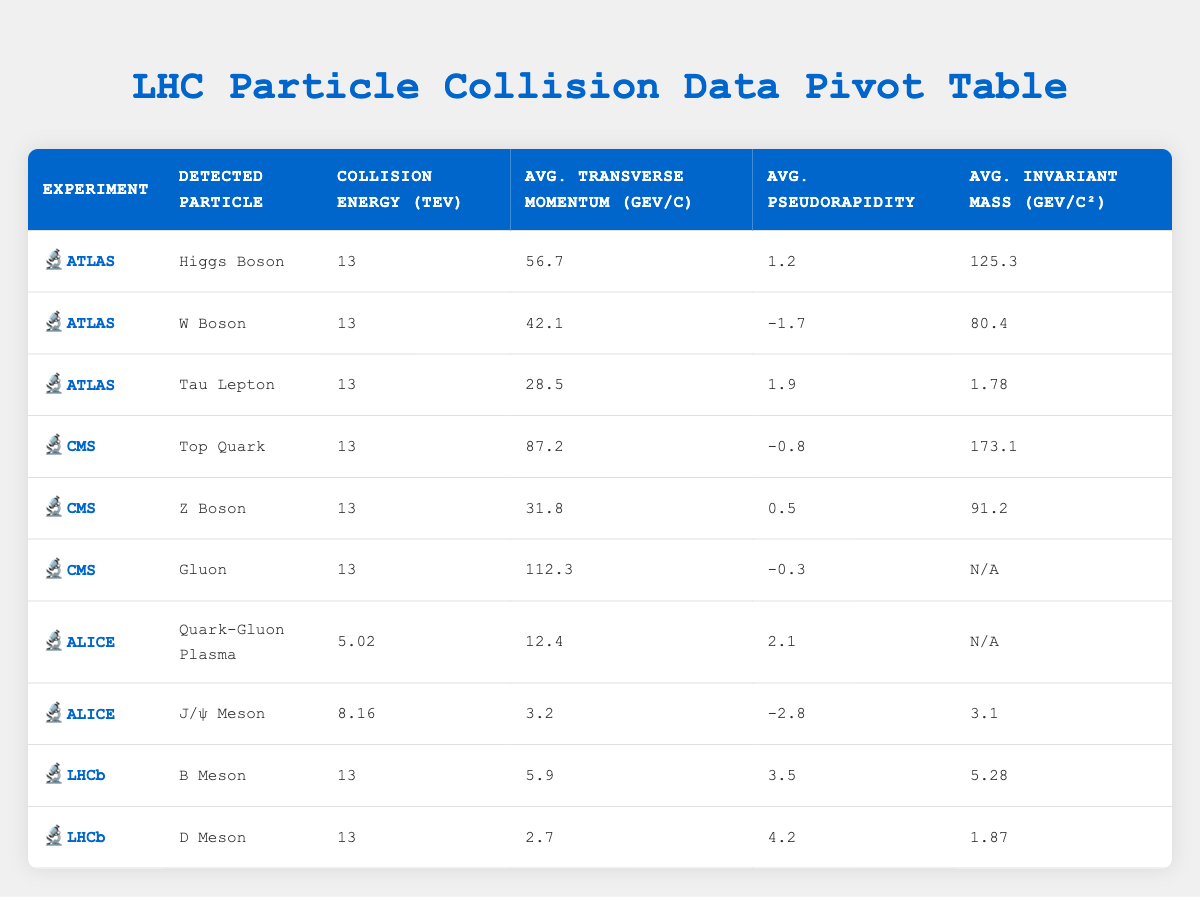What particle was detected in the ATLAS experiment in 2022? The ATLAS experiment in 2022 detected the Higgs Boson. This is found in the row corresponding to the ATLAS experiment with the year 2022 in the table.
Answer: Higgs Boson What is the collision energy for the experiments detecting the Z Boson? Looking at the table, the Z Boson was detected in the CMS experiment, which has a collision energy of 13 TeV. This is located in the corresponding row in the table.
Answer: 13 TeV Is the average transverse momentum for B Meson higher than that for Tau Lepton? The transverse momentum for B Meson is 5.9 GeV/c, while Tau Lepton's is 28.5 GeV/c. Since 28.5 is greater than 5.9, the average transverse momentum for Tau Lepton is indeed higher than that for B Meson.
Answer: Yes What is the average invariant mass of the particles detected in the ALICE experiment? In the ALICE experiment, the particles detected include Quark-Gluon Plasma (N/A for invariant mass) and J/ψ Meson (3.1 GeV/c²). The average can only be calculated by considering the J/ψ Meson, giving an average invariant mass of 3.1 GeV/c² because it's the only numeric value provided.
Answer: 3.1 GeV/c² What is the sum of the transverse momentum of all detected particles in the CMS experiment? The detected particles in the CMS experiment are Top Quark (87.2 GeV/c), Z Boson (31.8 GeV/c), and Gluon (112.3 GeV/c). The sum can be calculated as follows: 87.2 + 31.8 + 112.3 = 231.3 GeV/c. Therefore, the sum of transverse momentum for CMS is 231.3 GeV/c.
Answer: 231.3 GeV/c Which physicist detected the highest invariant mass among the detected particles? High invariant mass among detected particles is reported for the Top Quark with 173.1 GeV/c², identified in the row for CMS under the physicist Fabiola Gianotti. This is the highest value in the invariant mass column across all rows.
Answer: Fabiola Gianotti Was the collision energy for the lead-lead collisions in the ALICE experiment higher than 10 TeV? The collision energy for lead-lead collisions in the ALICE experiment is 5.02 TeV, which is less than 10 TeV. This is evident from the specific row detailing the ALICE experiment.
Answer: No What percentage of the detected particles were from proton-proton collisions? To get the percentage, we count the total entries: 10, and those from proton-proton collisions are 6 (Higgs Boson, W Boson, Tau Lepton, Top Quark, Z Boson, Gluon). Therefore, the percentage is (6/10) * 100 = 60%.
Answer: 60% 